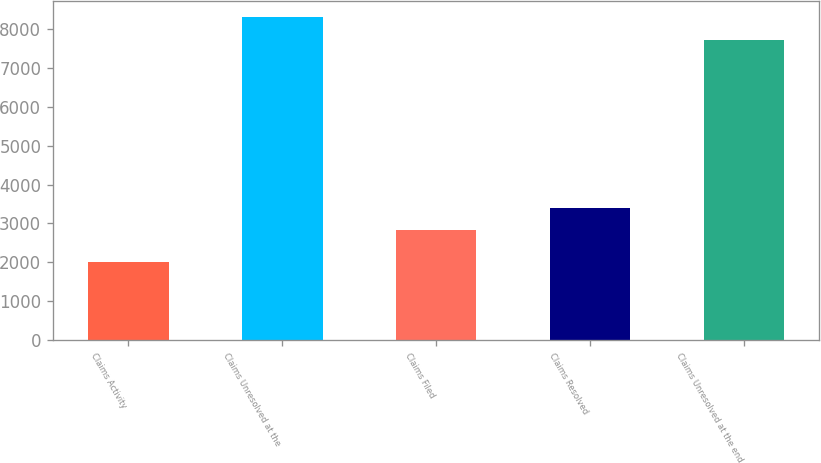Convert chart to OTSL. <chart><loc_0><loc_0><loc_500><loc_500><bar_chart><fcel>Claims Activity<fcel>Claims Unresolved at the<fcel>Claims Filed<fcel>Claims Resolved<fcel>Claims Unresolved at the end<nl><fcel>2016<fcel>8300.3<fcel>2830<fcel>3406.3<fcel>7724<nl></chart> 